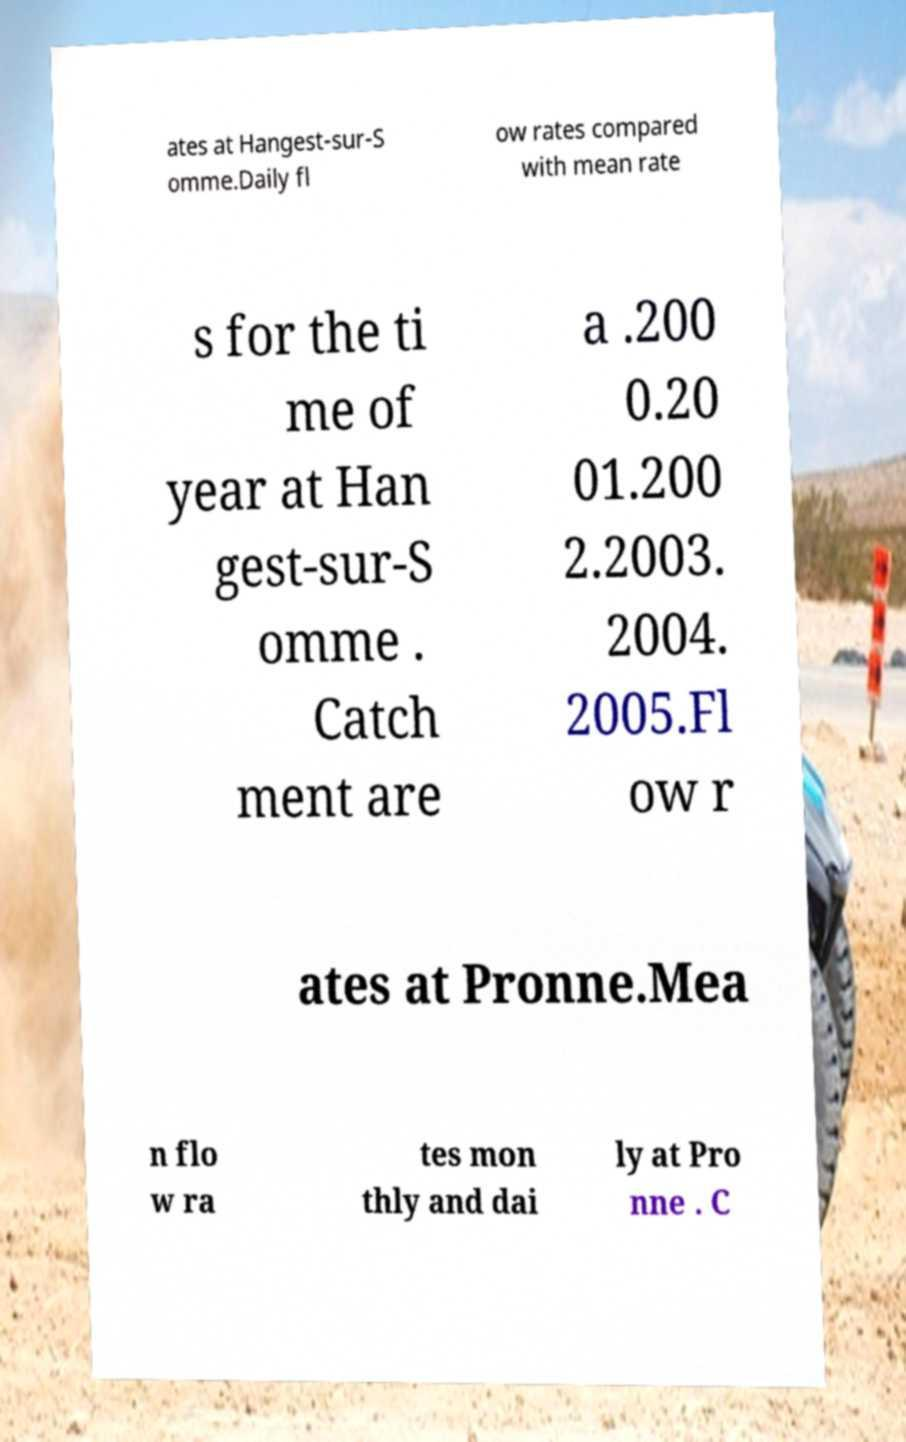Could you assist in decoding the text presented in this image and type it out clearly? ates at Hangest-sur-S omme.Daily fl ow rates compared with mean rate s for the ti me of year at Han gest-sur-S omme . Catch ment are a .200 0.20 01.200 2.2003. 2004. 2005.Fl ow r ates at Pronne.Mea n flo w ra tes mon thly and dai ly at Pro nne . C 